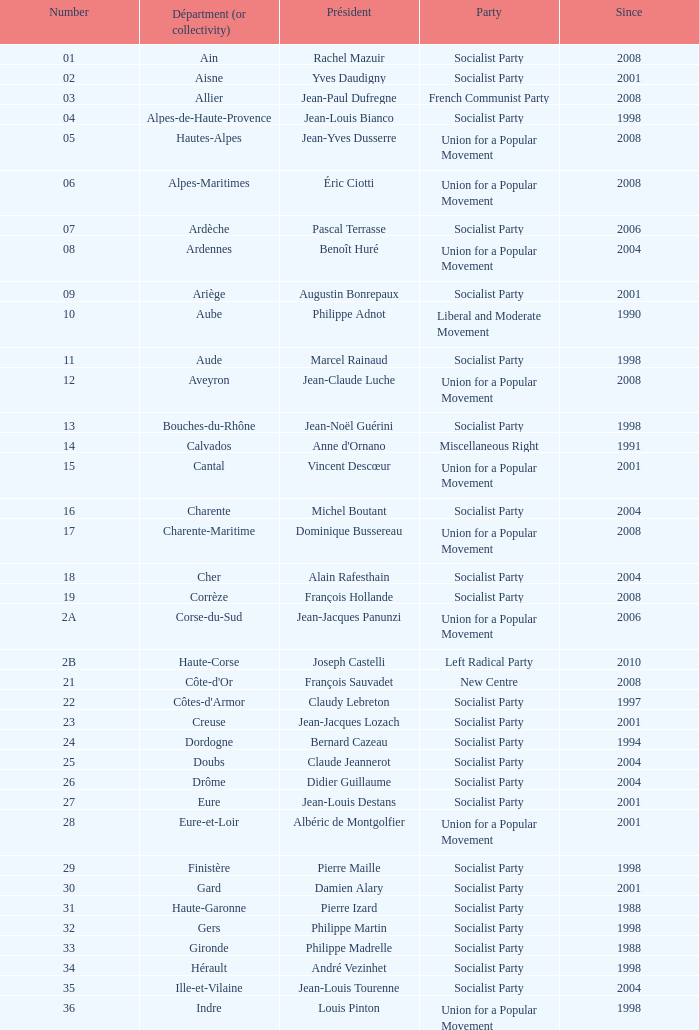Who is the president from the Union for a Popular Movement party that represents the Hautes-Alpes department? Jean-Yves Dusserre. 